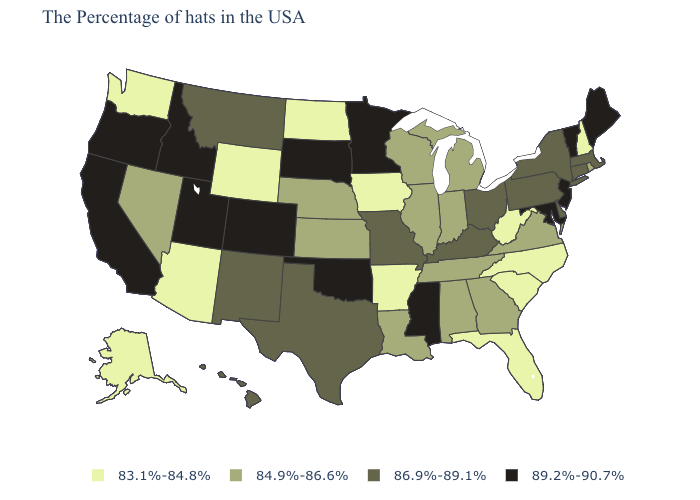What is the highest value in the USA?
Keep it brief. 89.2%-90.7%. Which states have the lowest value in the USA?
Write a very short answer. New Hampshire, North Carolina, South Carolina, West Virginia, Florida, Arkansas, Iowa, North Dakota, Wyoming, Arizona, Washington, Alaska. Does California have the highest value in the West?
Keep it brief. Yes. Which states have the lowest value in the Northeast?
Give a very brief answer. New Hampshire. Among the states that border Indiana , does Illinois have the highest value?
Be succinct. No. What is the highest value in states that border California?
Give a very brief answer. 89.2%-90.7%. What is the value of Colorado?
Short answer required. 89.2%-90.7%. What is the value of Ohio?
Be succinct. 86.9%-89.1%. What is the lowest value in states that border Kansas?
Be succinct. 84.9%-86.6%. What is the value of Wyoming?
Concise answer only. 83.1%-84.8%. Does Illinois have a higher value than Oregon?
Keep it brief. No. Name the states that have a value in the range 86.9%-89.1%?
Write a very short answer. Massachusetts, Connecticut, New York, Delaware, Pennsylvania, Ohio, Kentucky, Missouri, Texas, New Mexico, Montana, Hawaii. Is the legend a continuous bar?
Keep it brief. No. Name the states that have a value in the range 86.9%-89.1%?
Give a very brief answer. Massachusetts, Connecticut, New York, Delaware, Pennsylvania, Ohio, Kentucky, Missouri, Texas, New Mexico, Montana, Hawaii. Which states have the highest value in the USA?
Short answer required. Maine, Vermont, New Jersey, Maryland, Mississippi, Minnesota, Oklahoma, South Dakota, Colorado, Utah, Idaho, California, Oregon. 